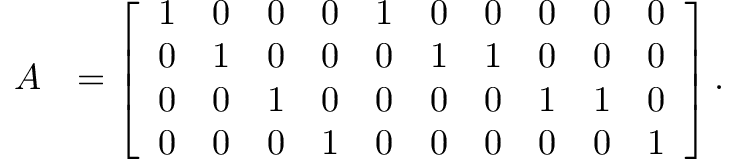Convert formula to latex. <formula><loc_0><loc_0><loc_500><loc_500>\begin{array} { r l } { A } & { = \left [ \begin{array} { l l l l l l l l l l } { 1 } & { 0 } & { 0 } & { 0 } & { 1 } & { 0 } & { 0 } & { 0 } & { 0 } & { 0 } \\ { 0 } & { 1 } & { 0 } & { 0 } & { 0 } & { 1 } & { 1 } & { 0 } & { 0 } & { 0 } \\ { 0 } & { 0 } & { 1 } & { 0 } & { 0 } & { 0 } & { 0 } & { 1 } & { 1 } & { 0 } \\ { 0 } & { 0 } & { 0 } & { 1 } & { 0 } & { 0 } & { 0 } & { 0 } & { 0 } & { 1 } \end{array} \right ] . } \end{array}</formula> 